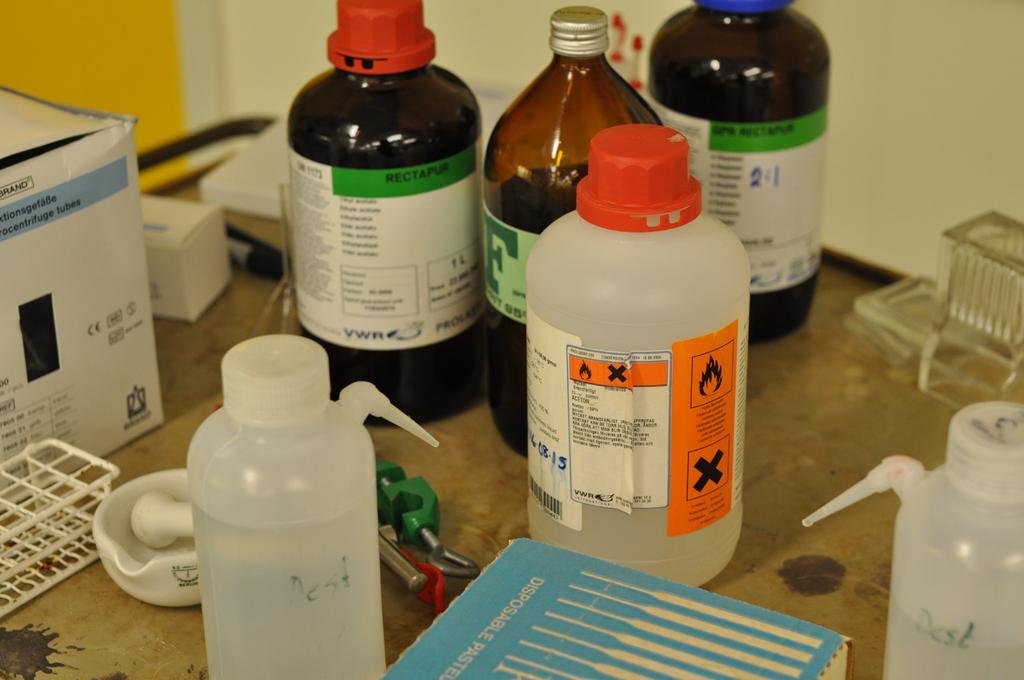What is the first word on the blue box at the bottom of the photo?
Keep it short and to the point. Disposable. What is the instruction given in the white bottle?
Your answer should be compact. Unanswerable. 